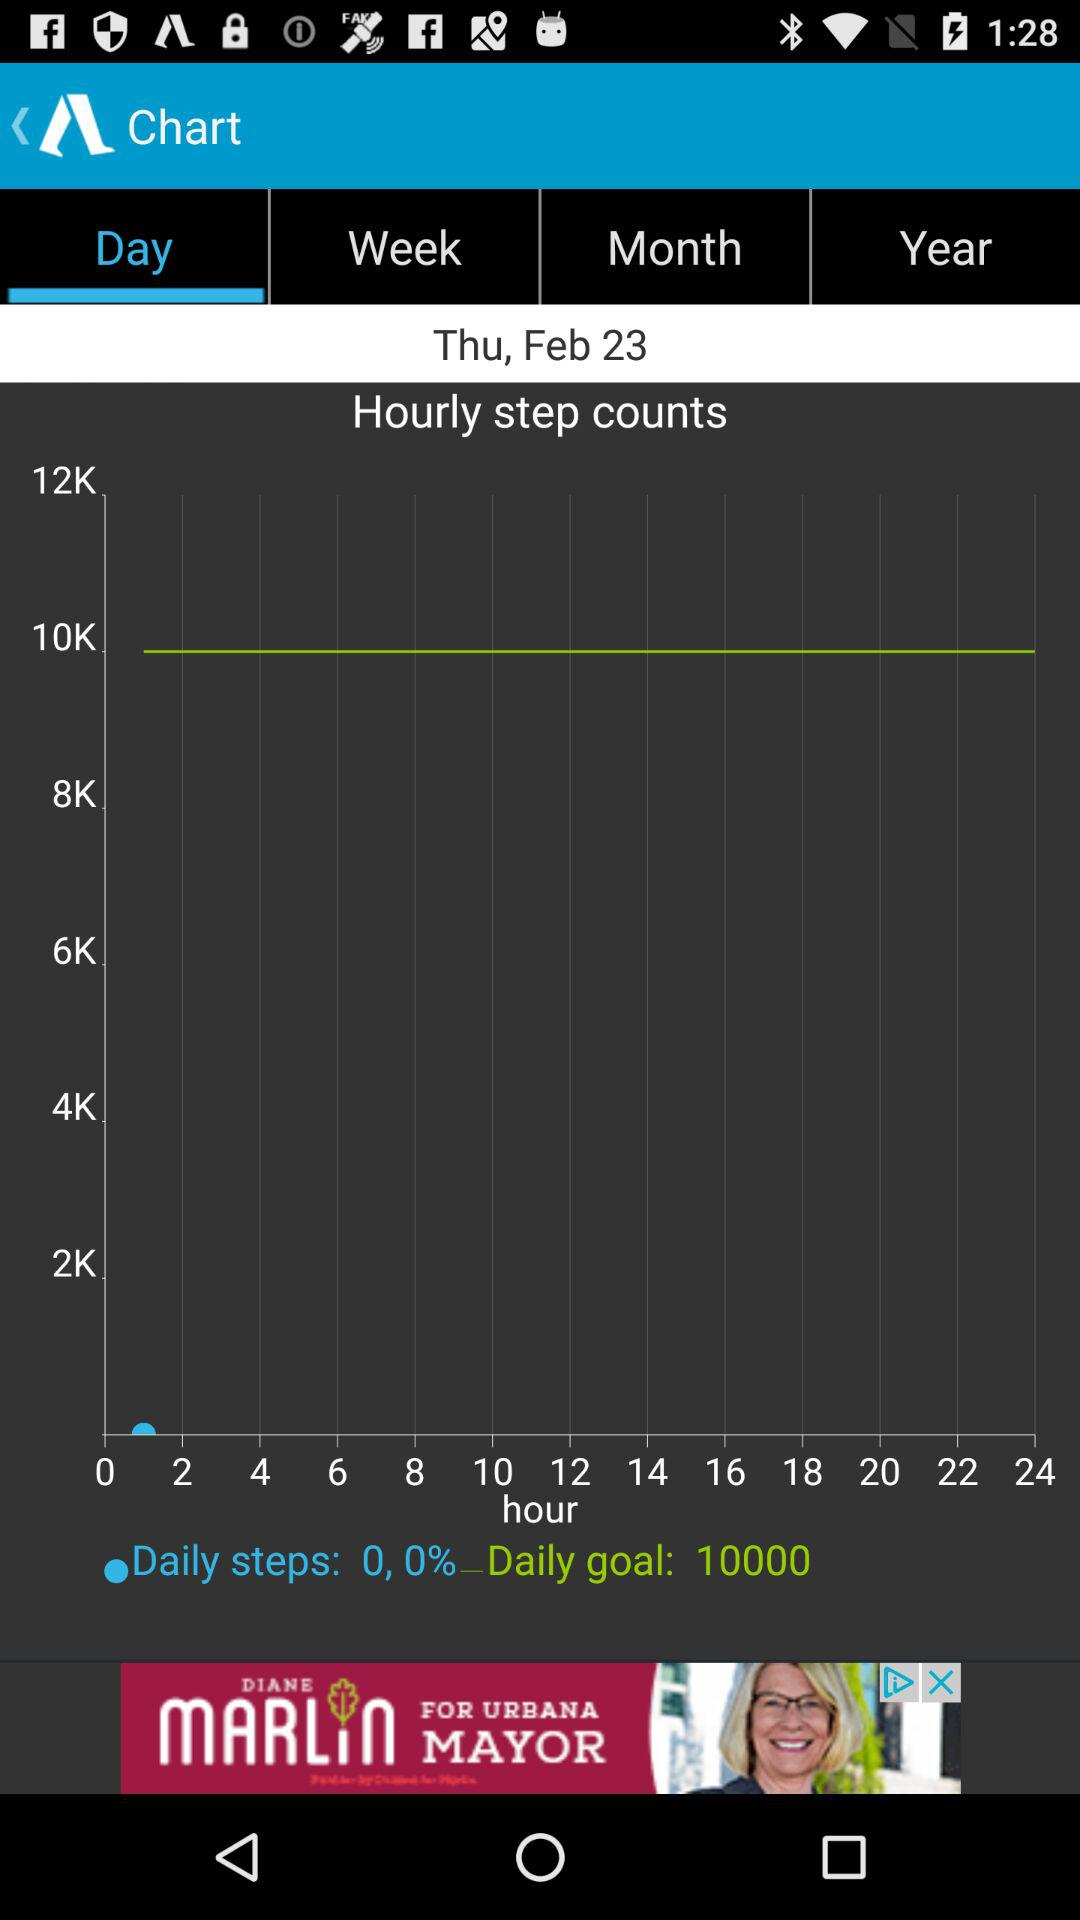What is the date? The date is Thursday, February 23. 